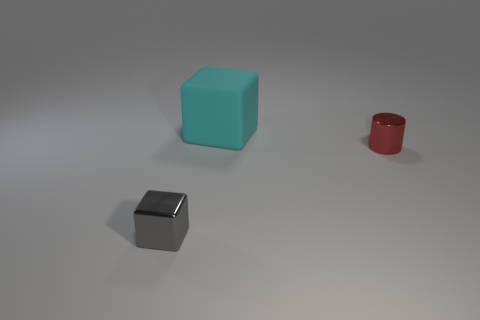Subtract all cyan blocks. How many blocks are left? 1 Add 3 big cyan rubber blocks. How many objects exist? 6 Subtract 1 cylinders. How many cylinders are left? 0 Subtract 1 red cylinders. How many objects are left? 2 Subtract all cylinders. How many objects are left? 2 Subtract all gray cylinders. Subtract all blue balls. How many cylinders are left? 1 Subtract all yellow balls. How many gray cubes are left? 1 Subtract all shiny things. Subtract all tiny blue rubber things. How many objects are left? 1 Add 3 gray things. How many gray things are left? 4 Add 1 tiny gray metal blocks. How many tiny gray metal blocks exist? 2 